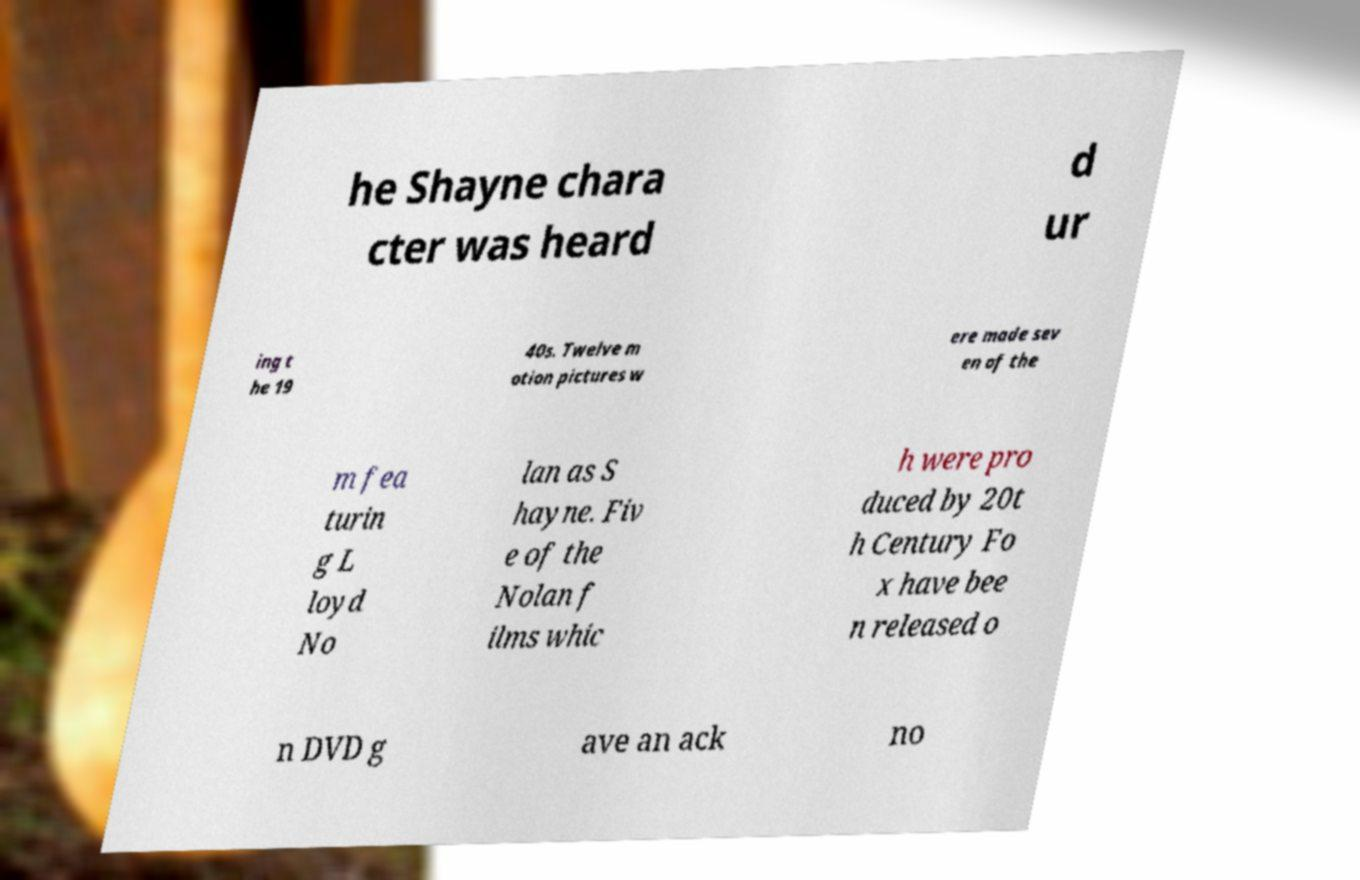Please read and relay the text visible in this image. What does it say? he Shayne chara cter was heard d ur ing t he 19 40s. Twelve m otion pictures w ere made sev en of the m fea turin g L loyd No lan as S hayne. Fiv e of the Nolan f ilms whic h were pro duced by 20t h Century Fo x have bee n released o n DVD g ave an ack no 